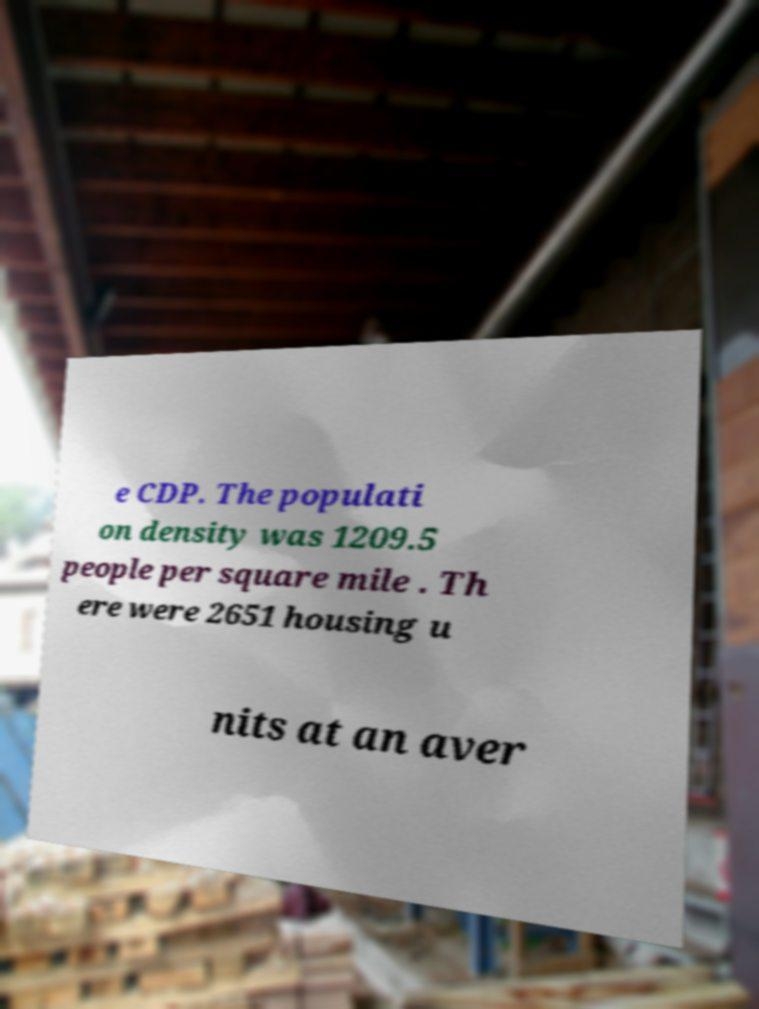For documentation purposes, I need the text within this image transcribed. Could you provide that? e CDP. The populati on density was 1209.5 people per square mile . Th ere were 2651 housing u nits at an aver 